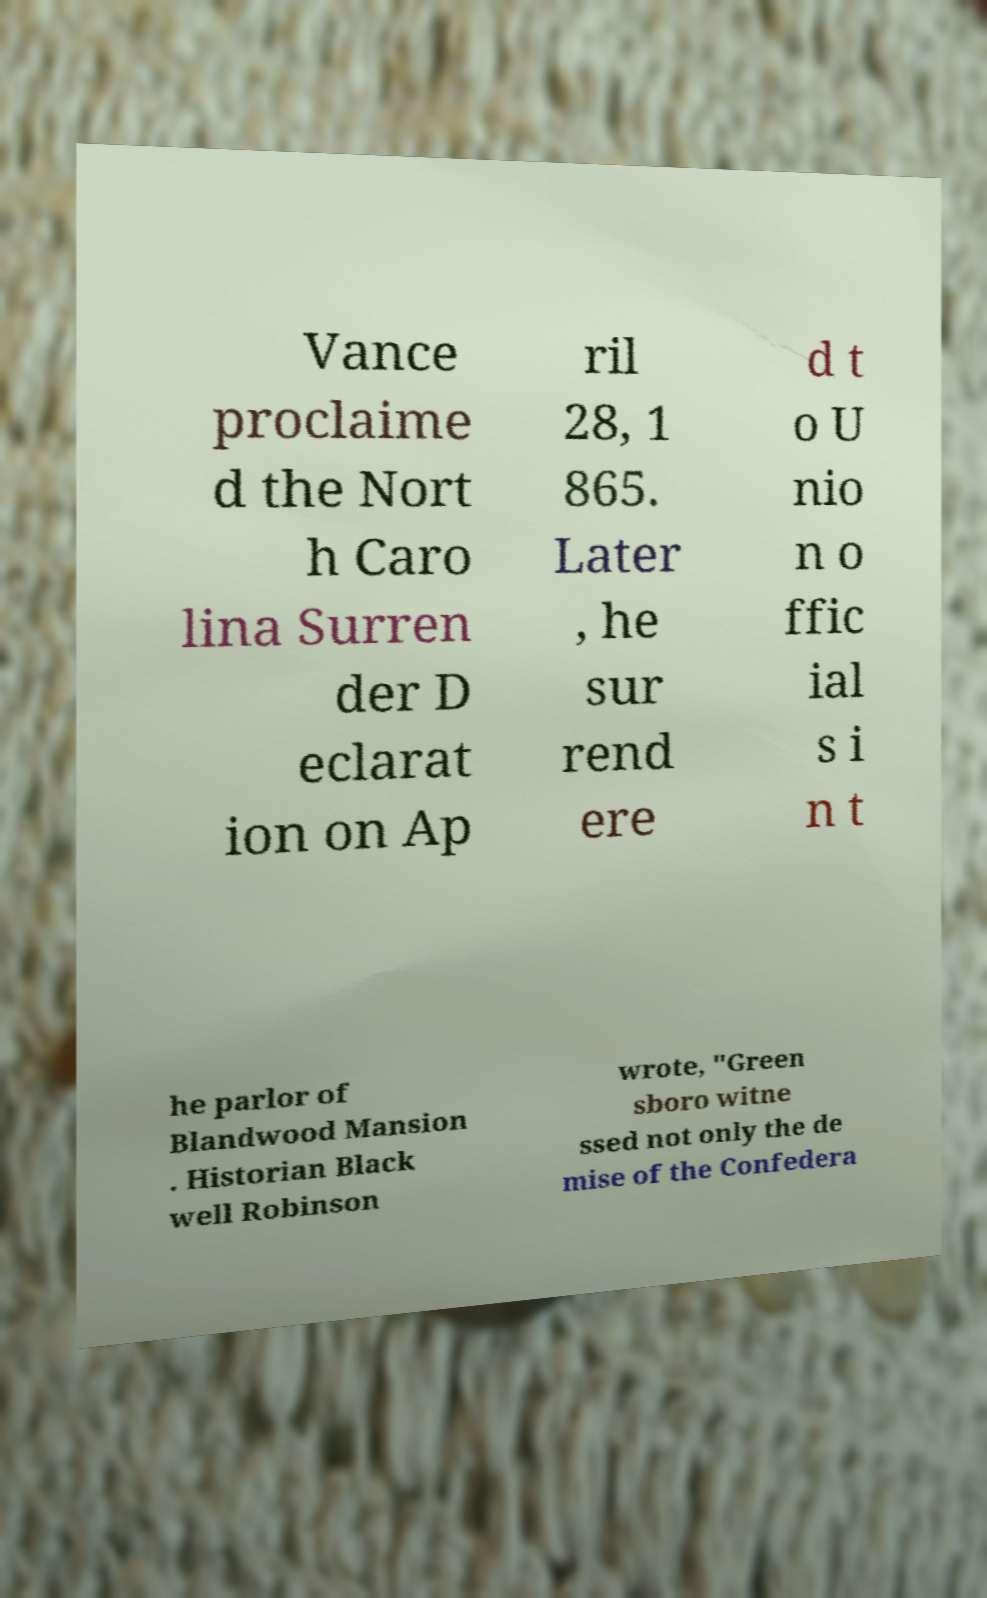Could you assist in decoding the text presented in this image and type it out clearly? Vance proclaime d the Nort h Caro lina Surren der D eclarat ion on Ap ril 28, 1 865. Later , he sur rend ere d t o U nio n o ffic ial s i n t he parlor of Blandwood Mansion . Historian Black well Robinson wrote, "Green sboro witne ssed not only the de mise of the Confedera 